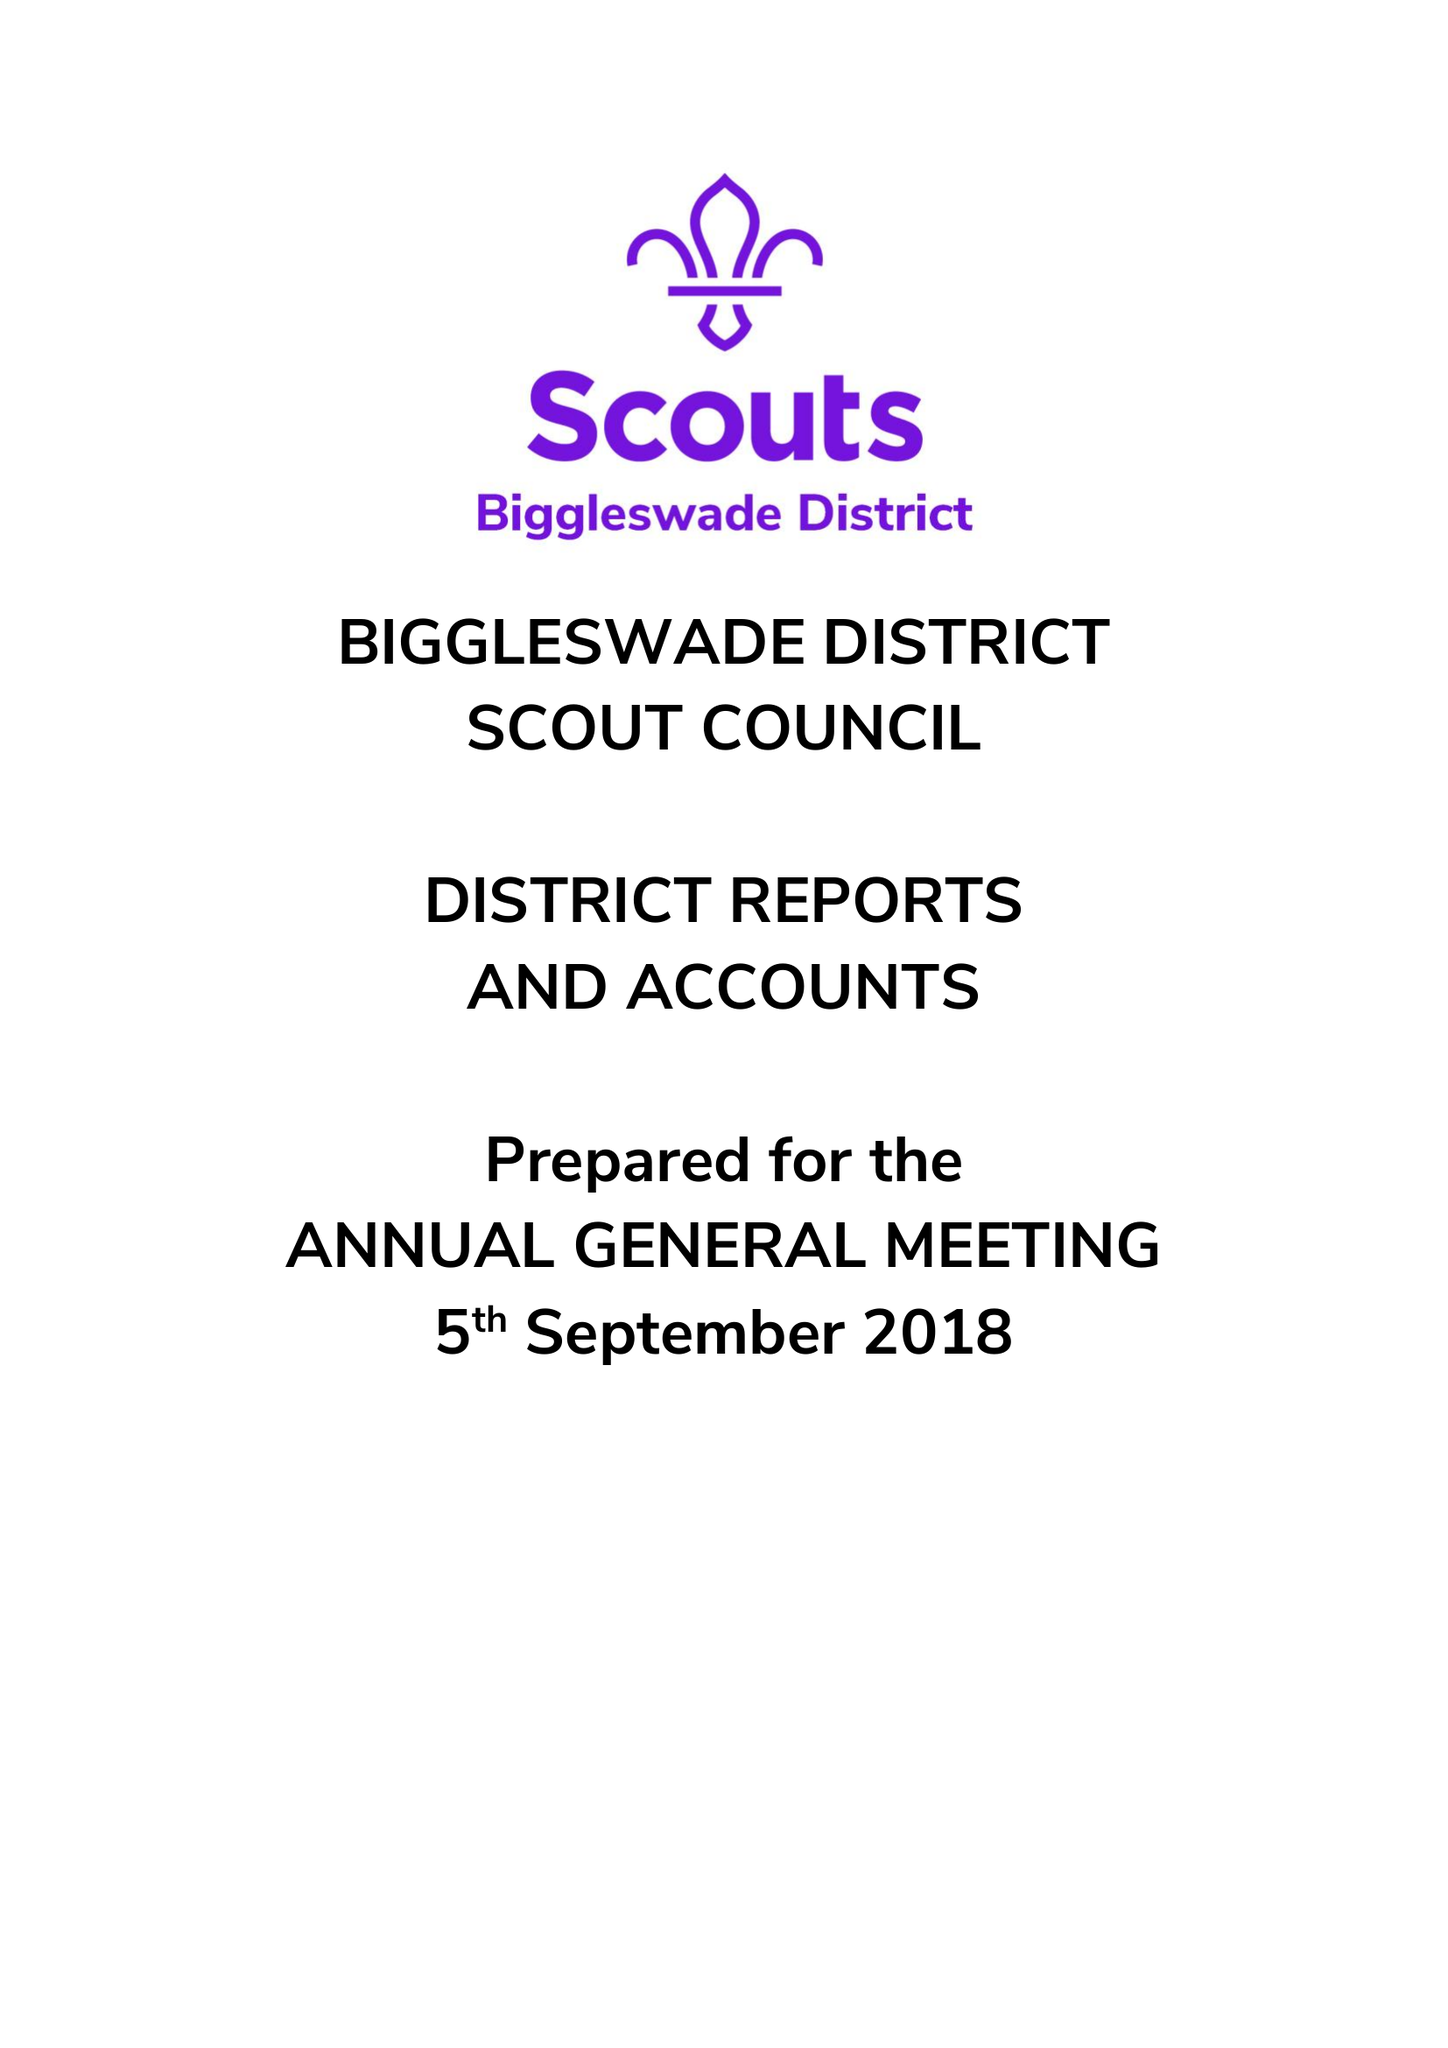What is the value for the address__post_town?
Answer the question using a single word or phrase. BIGGLESWADE 